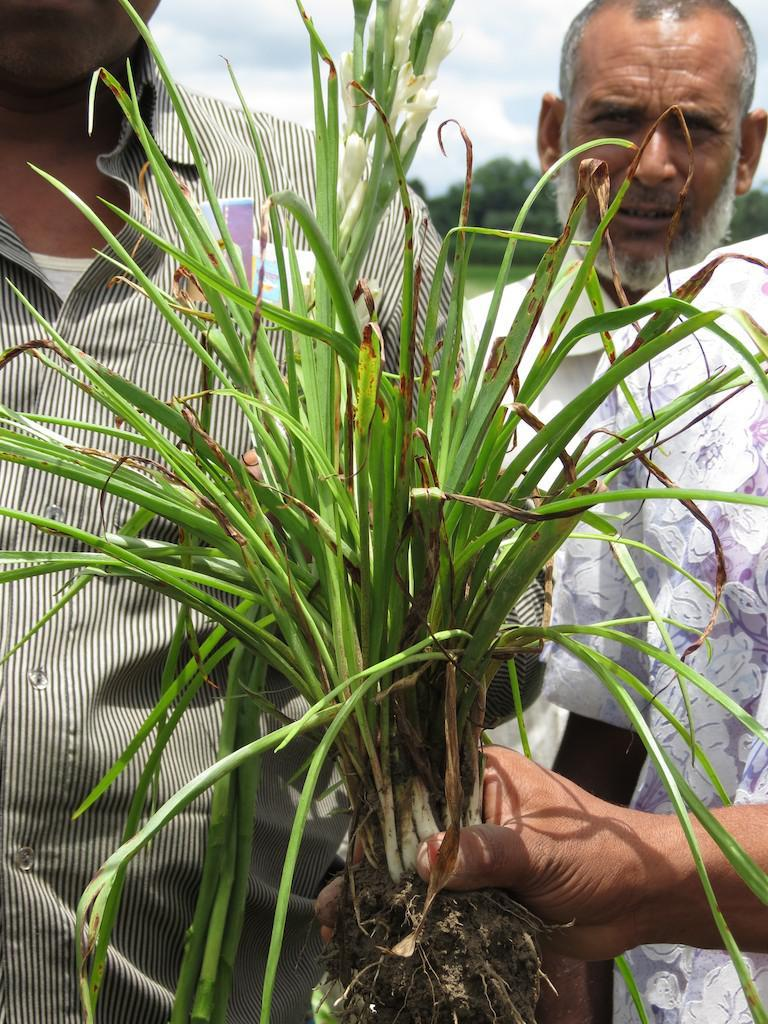What is the person in the image holding? The person is holding a plant in the image. How many people are present in the image? There are people standing in the image. What can be seen in the background of the image? Trees and the sky are visible in the background of the image. What is the condition of the sky in the image? The sky appears to be cloudy in the image. What type of connection can be seen between the person and the plant in the image? There is no specific connection between the person and the plant in the image; the person is simply holding the plant. What word is being used to describe the oranges in the image? There are no oranges present in the image, so it is not possible to describe any words related to them. 